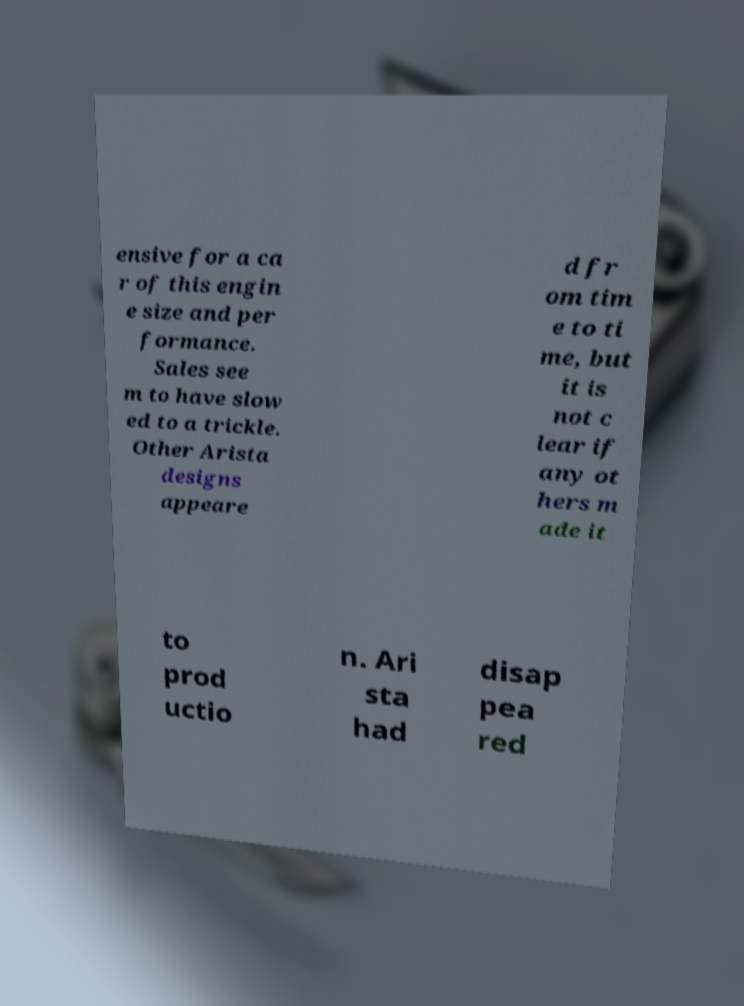I need the written content from this picture converted into text. Can you do that? ensive for a ca r of this engin e size and per formance. Sales see m to have slow ed to a trickle. Other Arista designs appeare d fr om tim e to ti me, but it is not c lear if any ot hers m ade it to prod uctio n. Ari sta had disap pea red 